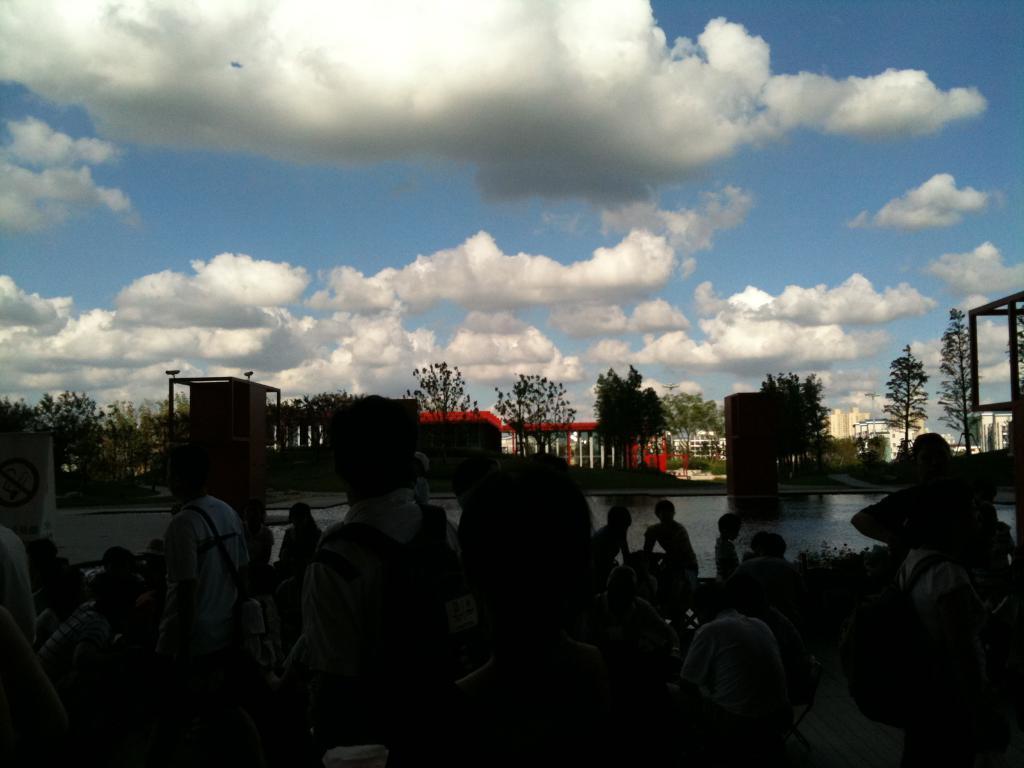In one or two sentences, can you explain what this image depicts? In the image there are many people standing and sitting in the front and behind them there is a lake followed by buildings and trees in the background and above its sky with clouds. 